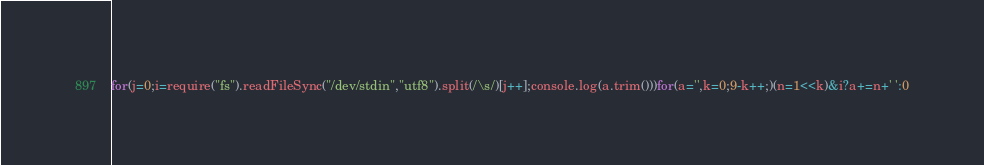<code> <loc_0><loc_0><loc_500><loc_500><_JavaScript_>for(j=0;i=require("fs").readFileSync("/dev/stdin","utf8").split(/\s/)[j++];console.log(a.trim()))for(a='',k=0;9-k++;)(n=1<<k)&i?a+=n+' ':0</code> 